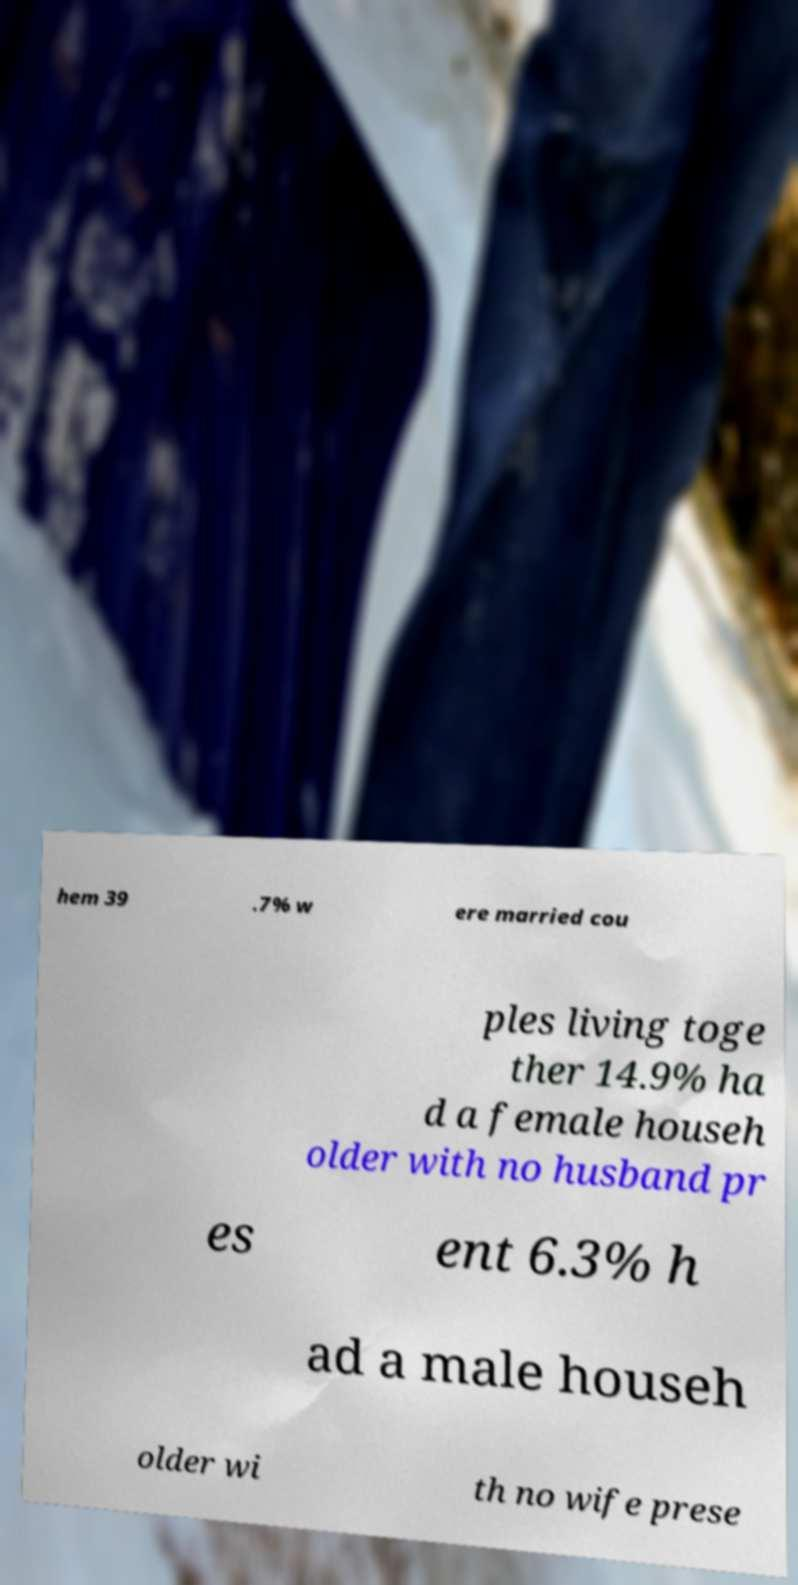Can you read and provide the text displayed in the image?This photo seems to have some interesting text. Can you extract and type it out for me? hem 39 .7% w ere married cou ples living toge ther 14.9% ha d a female househ older with no husband pr es ent 6.3% h ad a male househ older wi th no wife prese 